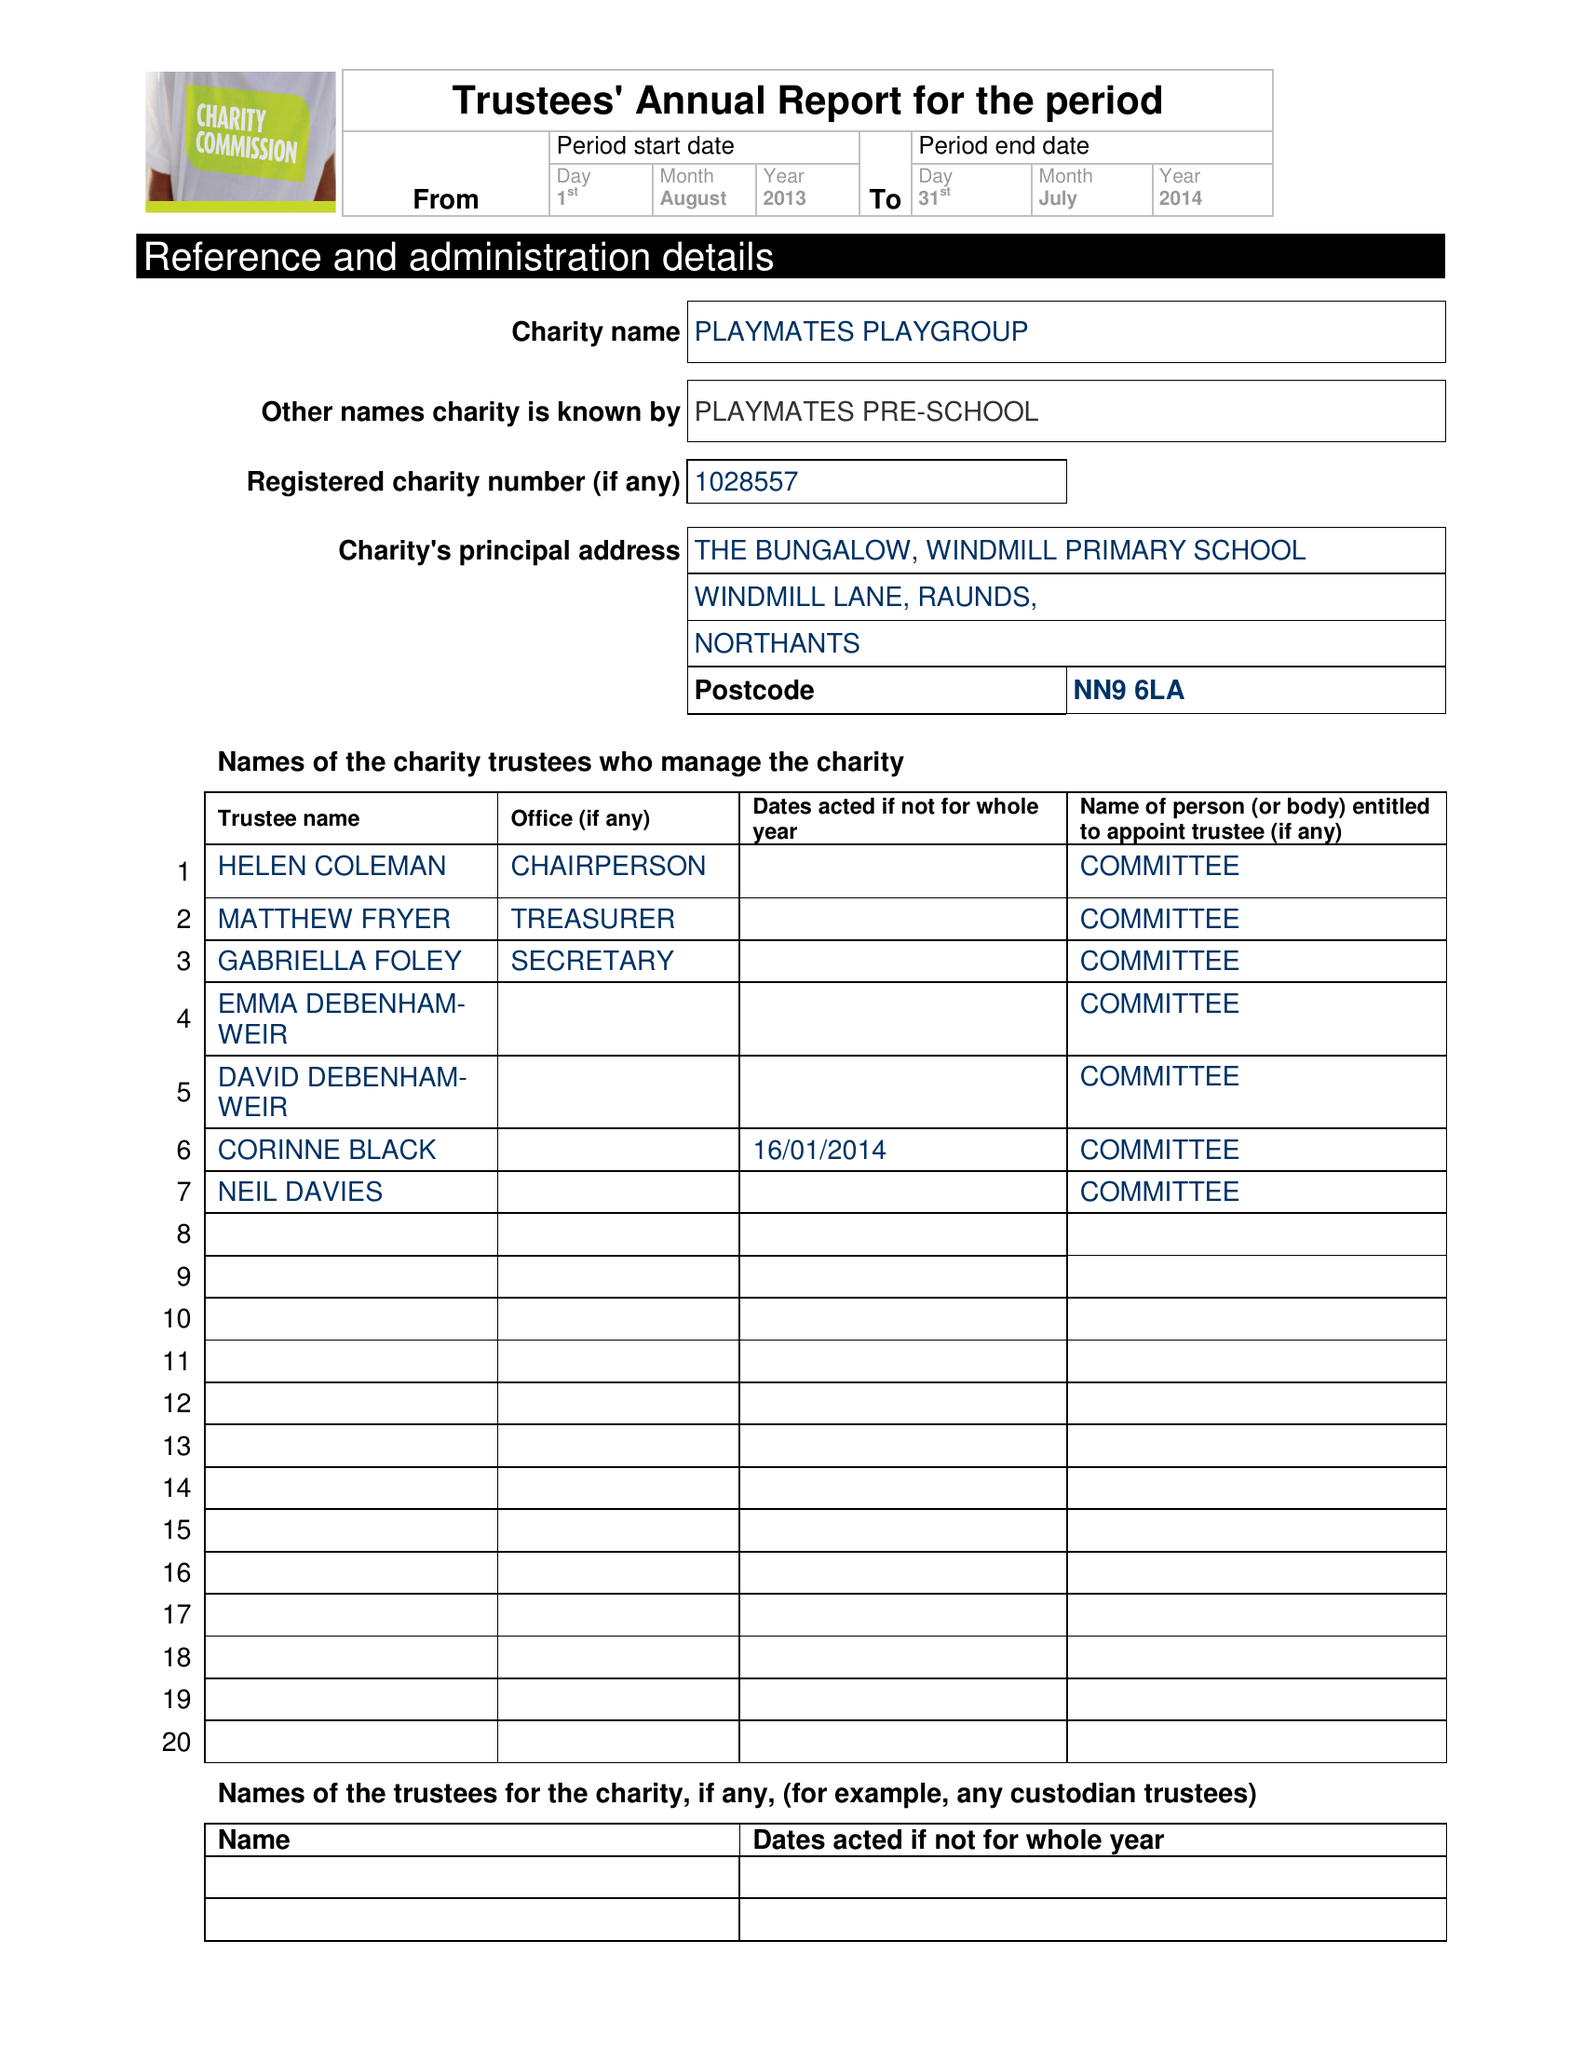What is the value for the charity_number?
Answer the question using a single word or phrase. 1028557 